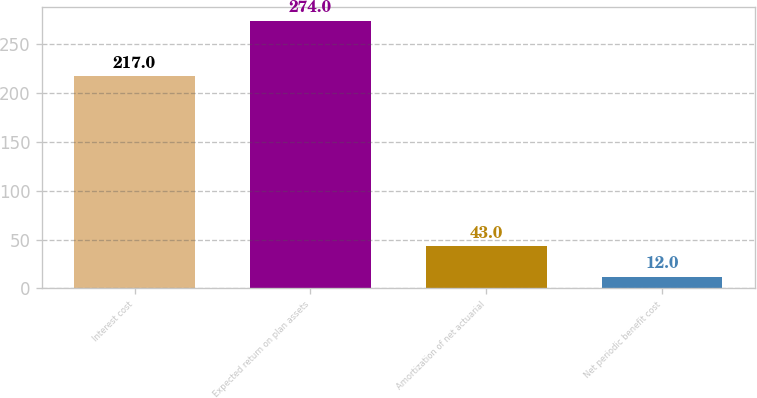Convert chart. <chart><loc_0><loc_0><loc_500><loc_500><bar_chart><fcel>Interest cost<fcel>Expected return on plan assets<fcel>Amortization of net actuarial<fcel>Net periodic benefit cost<nl><fcel>217<fcel>274<fcel>43<fcel>12<nl></chart> 